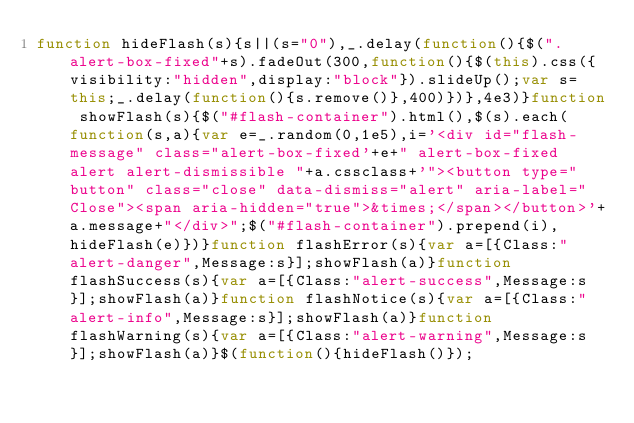<code> <loc_0><loc_0><loc_500><loc_500><_JavaScript_>function hideFlash(s){s||(s="0"),_.delay(function(){$(".alert-box-fixed"+s).fadeOut(300,function(){$(this).css({visibility:"hidden",display:"block"}).slideUp();var s=this;_.delay(function(){s.remove()},400)})},4e3)}function showFlash(s){$("#flash-container").html(),$(s).each(function(s,a){var e=_.random(0,1e5),i='<div id="flash-message" class="alert-box-fixed'+e+" alert-box-fixed alert alert-dismissible "+a.cssclass+'"><button type="button" class="close" data-dismiss="alert" aria-label="Close"><span aria-hidden="true">&times;</span></button>'+a.message+"</div>";$("#flash-container").prepend(i),hideFlash(e)})}function flashError(s){var a=[{Class:"alert-danger",Message:s}];showFlash(a)}function flashSuccess(s){var a=[{Class:"alert-success",Message:s}];showFlash(a)}function flashNotice(s){var a=[{Class:"alert-info",Message:s}];showFlash(a)}function flashWarning(s){var a=[{Class:"alert-warning",Message:s}];showFlash(a)}$(function(){hideFlash()});</code> 